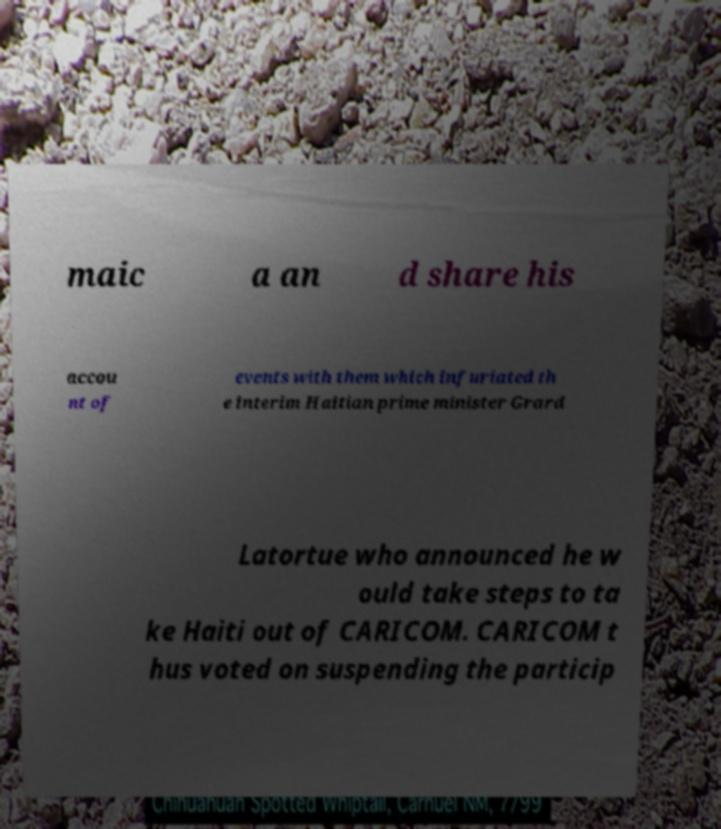What messages or text are displayed in this image? I need them in a readable, typed format. maic a an d share his accou nt of events with them which infuriated th e interim Haitian prime minister Grard Latortue who announced he w ould take steps to ta ke Haiti out of CARICOM. CARICOM t hus voted on suspending the particip 